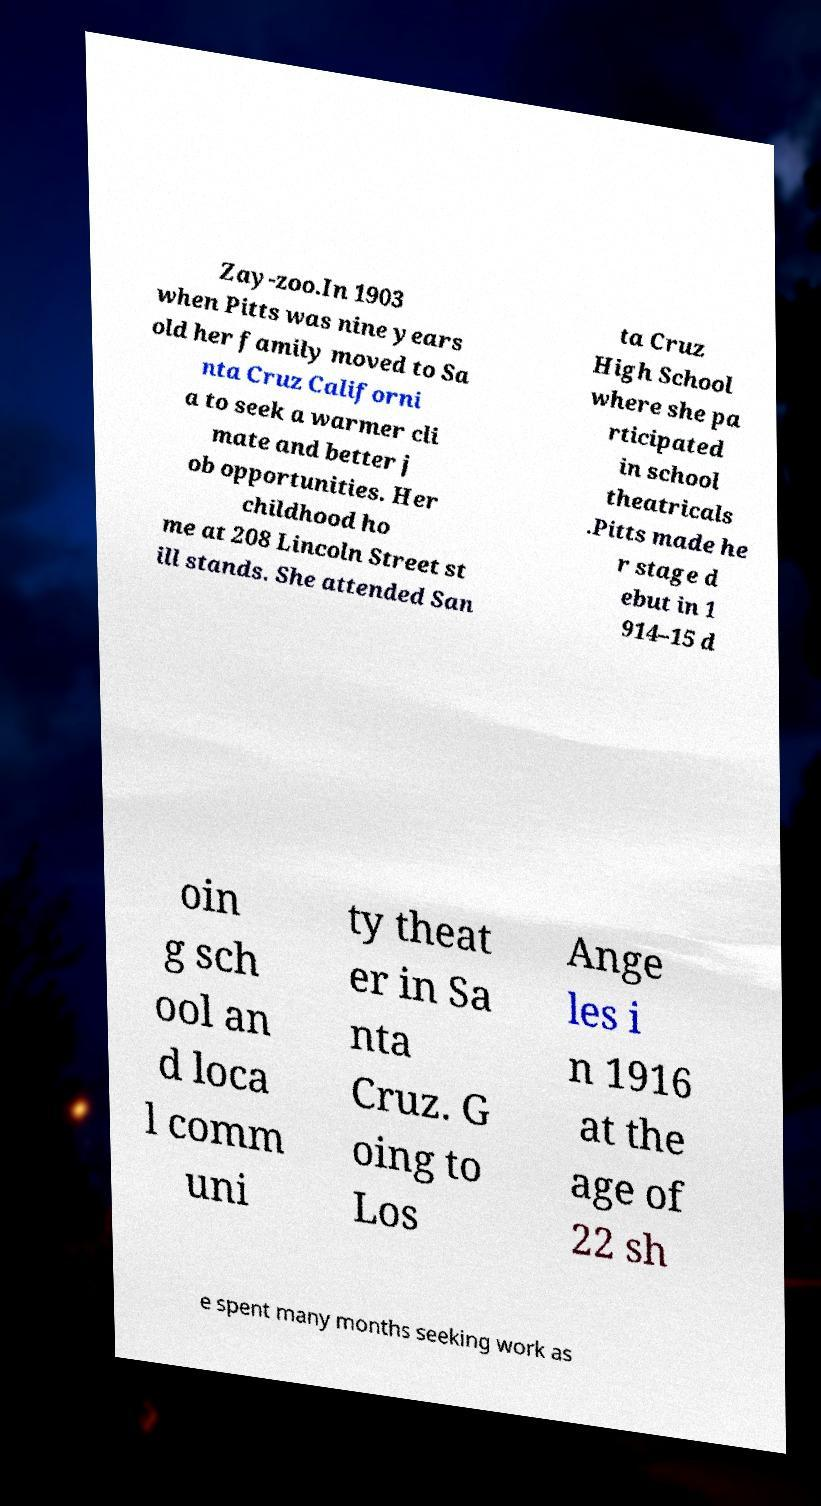Can you accurately transcribe the text from the provided image for me? Zay-zoo.In 1903 when Pitts was nine years old her family moved to Sa nta Cruz Californi a to seek a warmer cli mate and better j ob opportunities. Her childhood ho me at 208 Lincoln Street st ill stands. She attended San ta Cruz High School where she pa rticipated in school theatricals .Pitts made he r stage d ebut in 1 914–15 d oin g sch ool an d loca l comm uni ty theat er in Sa nta Cruz. G oing to Los Ange les i n 1916 at the age of 22 sh e spent many months seeking work as 